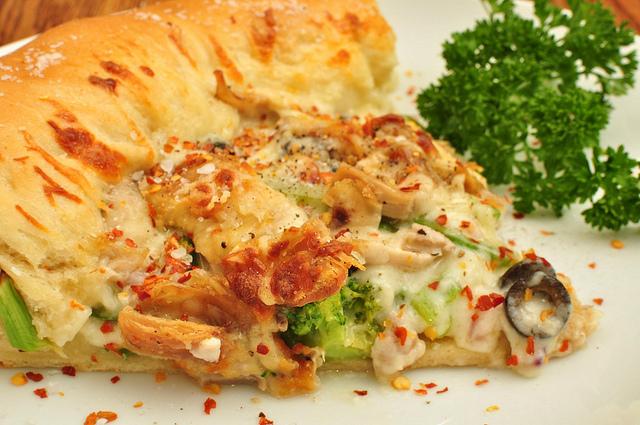What color is the garnish to the right of the food?
Keep it brief. Green. Is this meal healthy?
Give a very brief answer. No. What color is the plate?
Quick response, please. White. Would that be a good crust?
Write a very short answer. Yes. What kind of food is this?
Answer briefly. Pizza. 